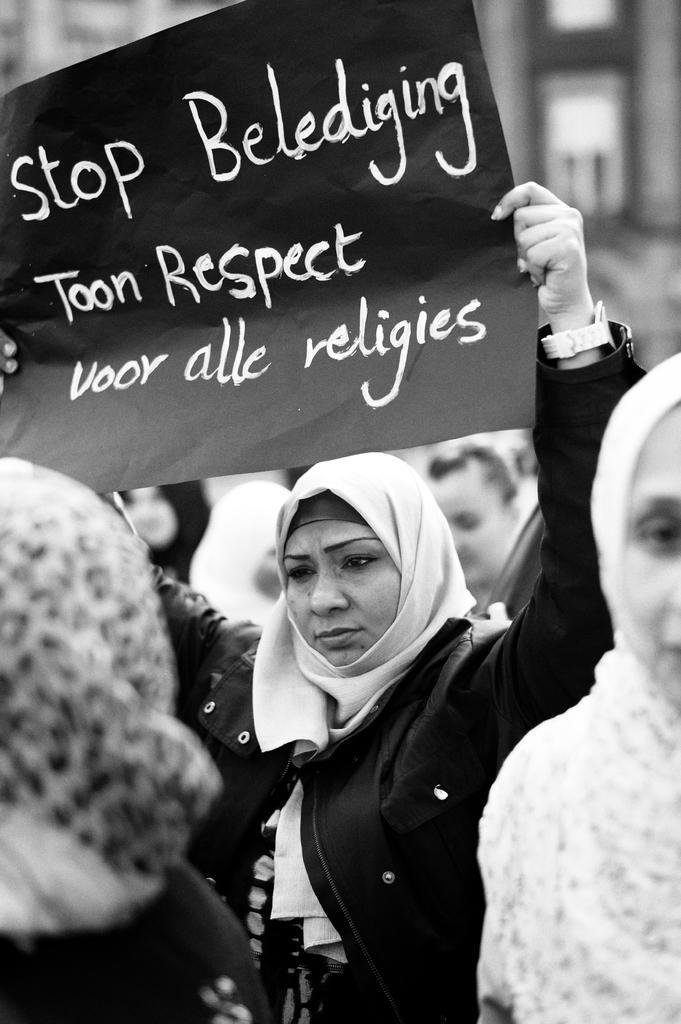Describe this image in one or two sentences. In this image in the middle there is a woman, she wears a dress, she is holding a poster. On the right there is a woman. On the left there is a woman. In the background there are some people, buildings. 